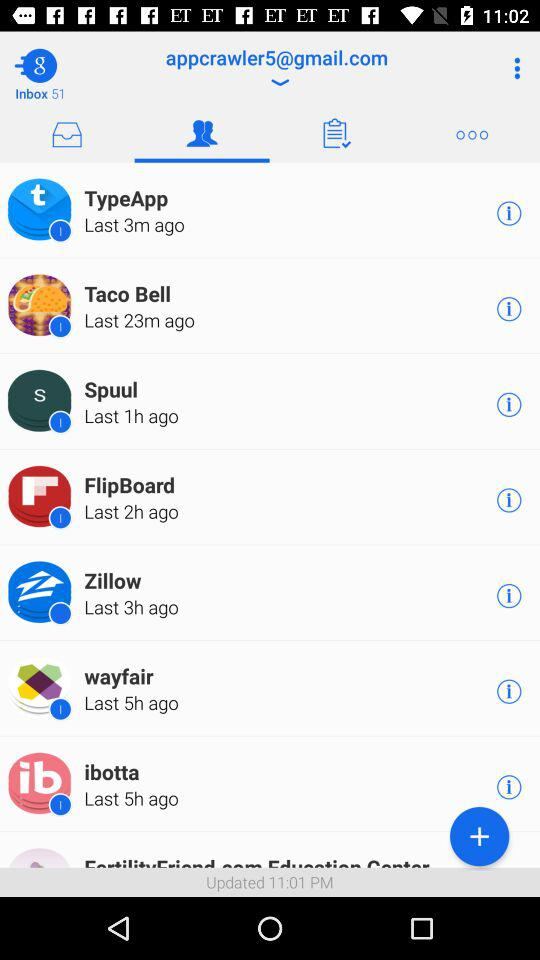How many more minutes ago was the last message sent from Spuul compared to the last message sent from Flipboard?
Answer the question using a single word or phrase. 1 hour 